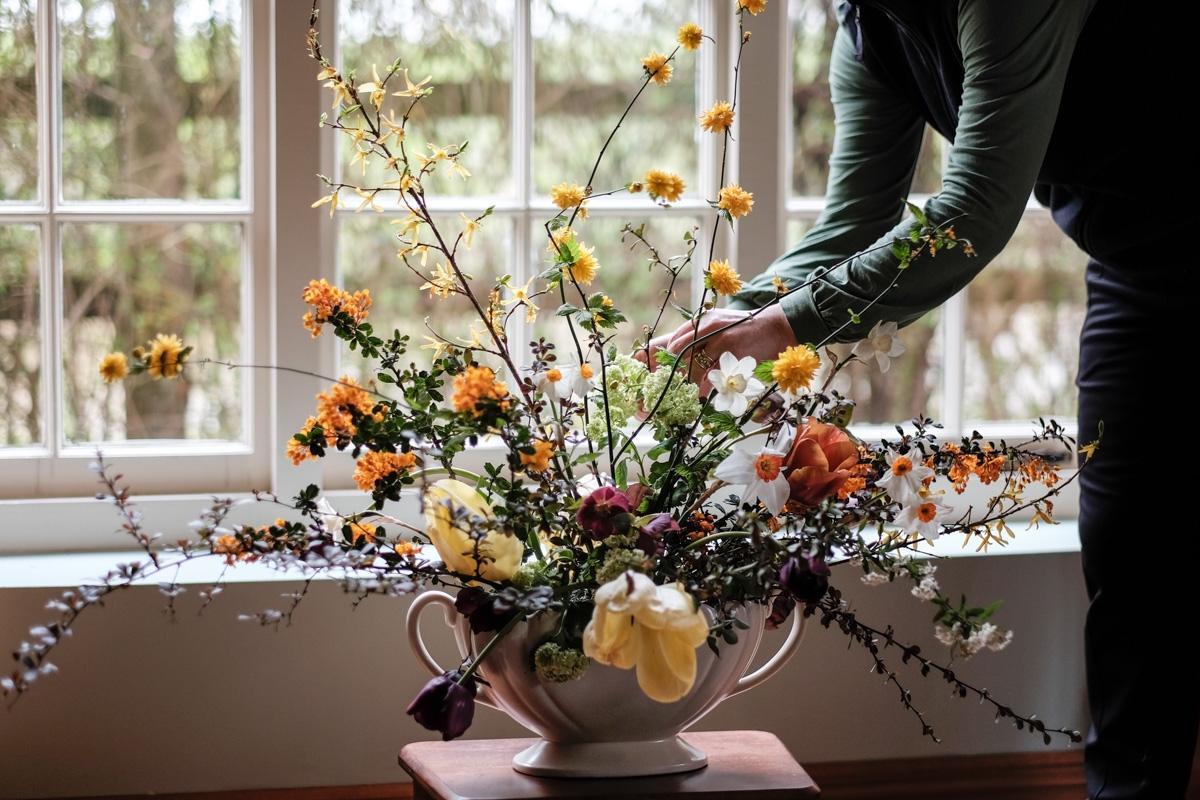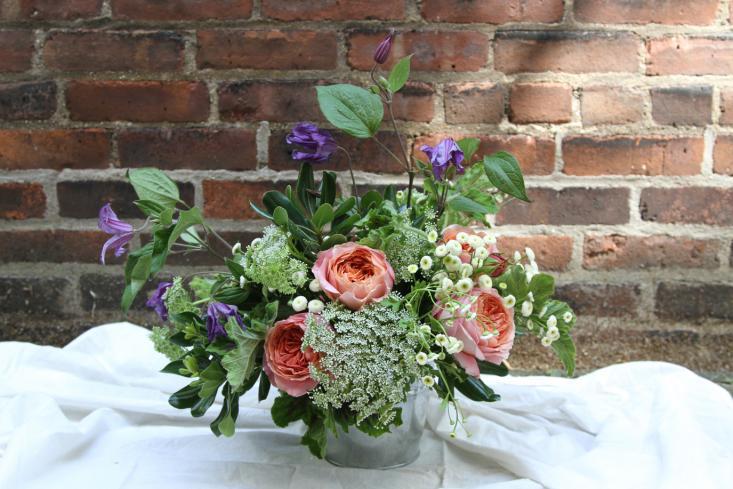The first image is the image on the left, the second image is the image on the right. Given the left and right images, does the statement "In one of the images there is at least one bouquet in a clear glass vase." hold true? Answer yes or no. No. The first image is the image on the left, the second image is the image on the right. Assess this claim about the two images: "One image features a single floral arrangement, which includes long stems with yellow flowers in an opaque container with at least one handle.". Correct or not? Answer yes or no. Yes. 